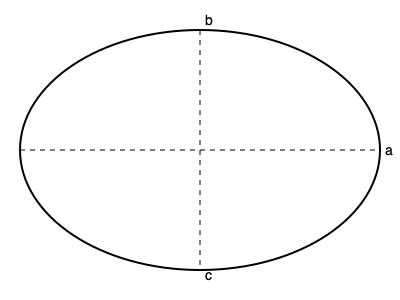As a farmer delivering natural materials for crafting, you need to estimate the volume of an irregularly shaped gourd. The gourd can be approximated as an ellipsoid with semi-axes lengths of $a = 18$ cm, $b = 12$ cm, and $c = 15$ cm. Calculate the volume of the gourd in cubic centimeters (cm³), rounded to the nearest whole number. To calculate the volume of an ellipsoid, we can use the formula:

$$V = \frac{4}{3}\pi abc$$

Where:
$V$ is the volume
$a$, $b$, and $c$ are the semi-axes lengths of the ellipsoid

Given:
$a = 18$ cm
$b = 12$ cm
$c = 15$ cm

Let's substitute these values into the formula:

$$V = \frac{4}{3}\pi(18)(12)(15)$$

Simplifying:

$$V = \frac{4}{3}\pi(3240)$$

$$V = 4320\pi$$

Using $\pi \approx 3.14159$, we get:

$$V \approx 4320(3.14159)$$

$$V \approx 13571.6688\text{ cm}^3$$

Rounding to the nearest whole number:

$$V \approx 13572\text{ cm}^3$$
Answer: 13572 cm³ 